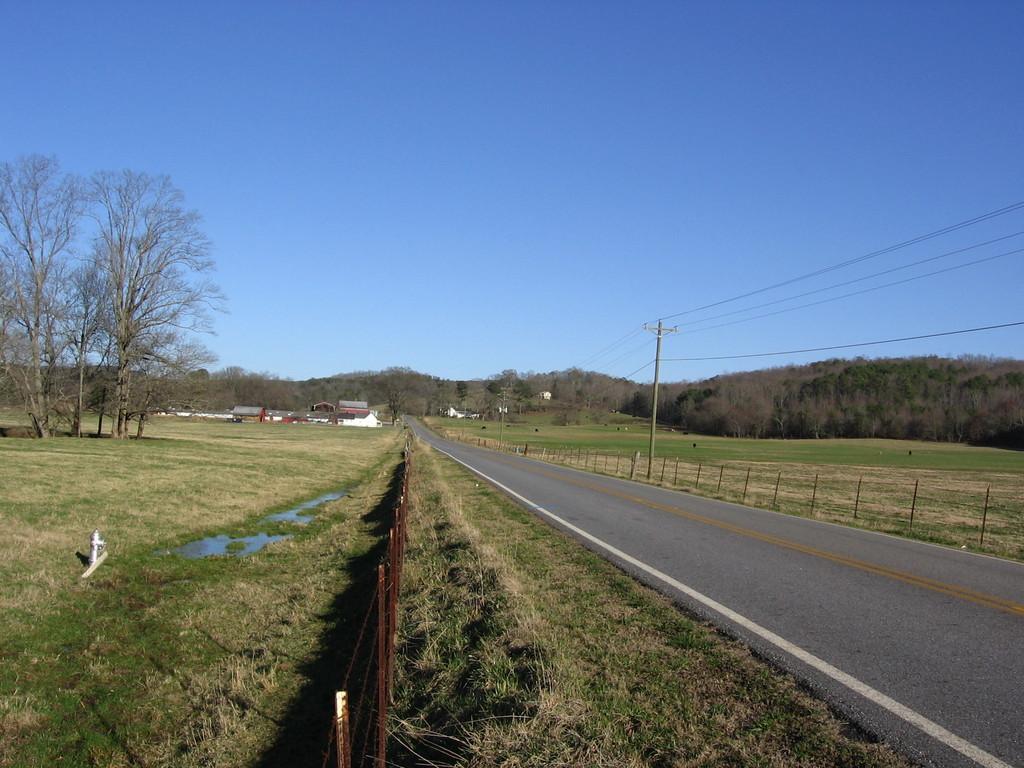Can you describe this image briefly? In this image we can see there are some trees, houses, poles, wires, grass, fence, hydrant and the road, in the background we can see the sky. 